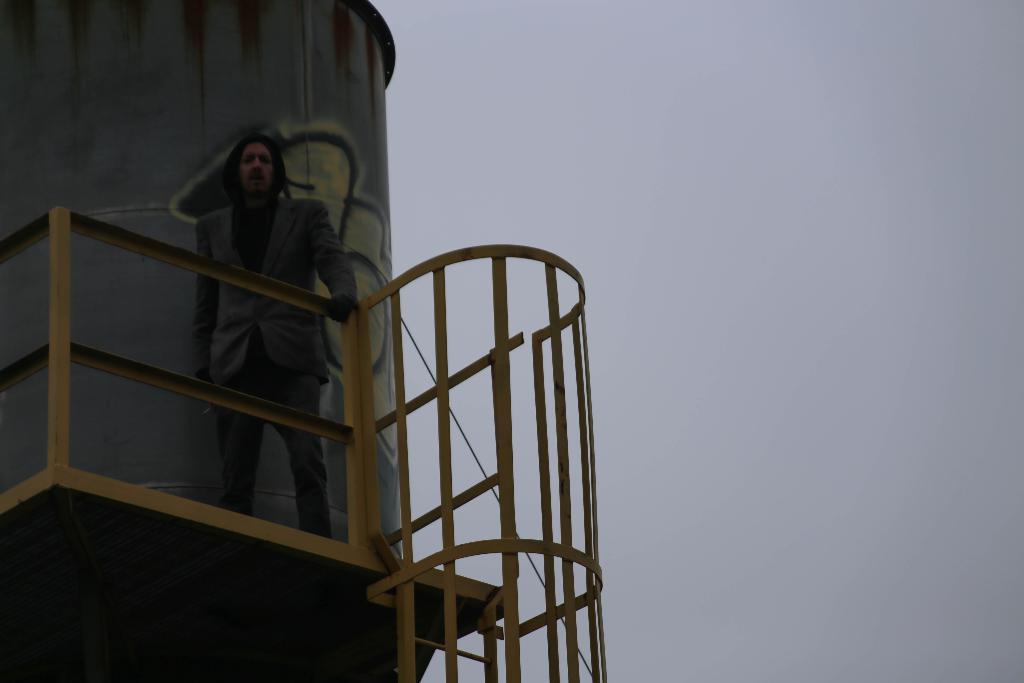In one or two sentences, can you explain what this image depicts? On the right side there is sky. On the left side there is a cylinder shaped object and a person is standing. Near to him there are railings. 